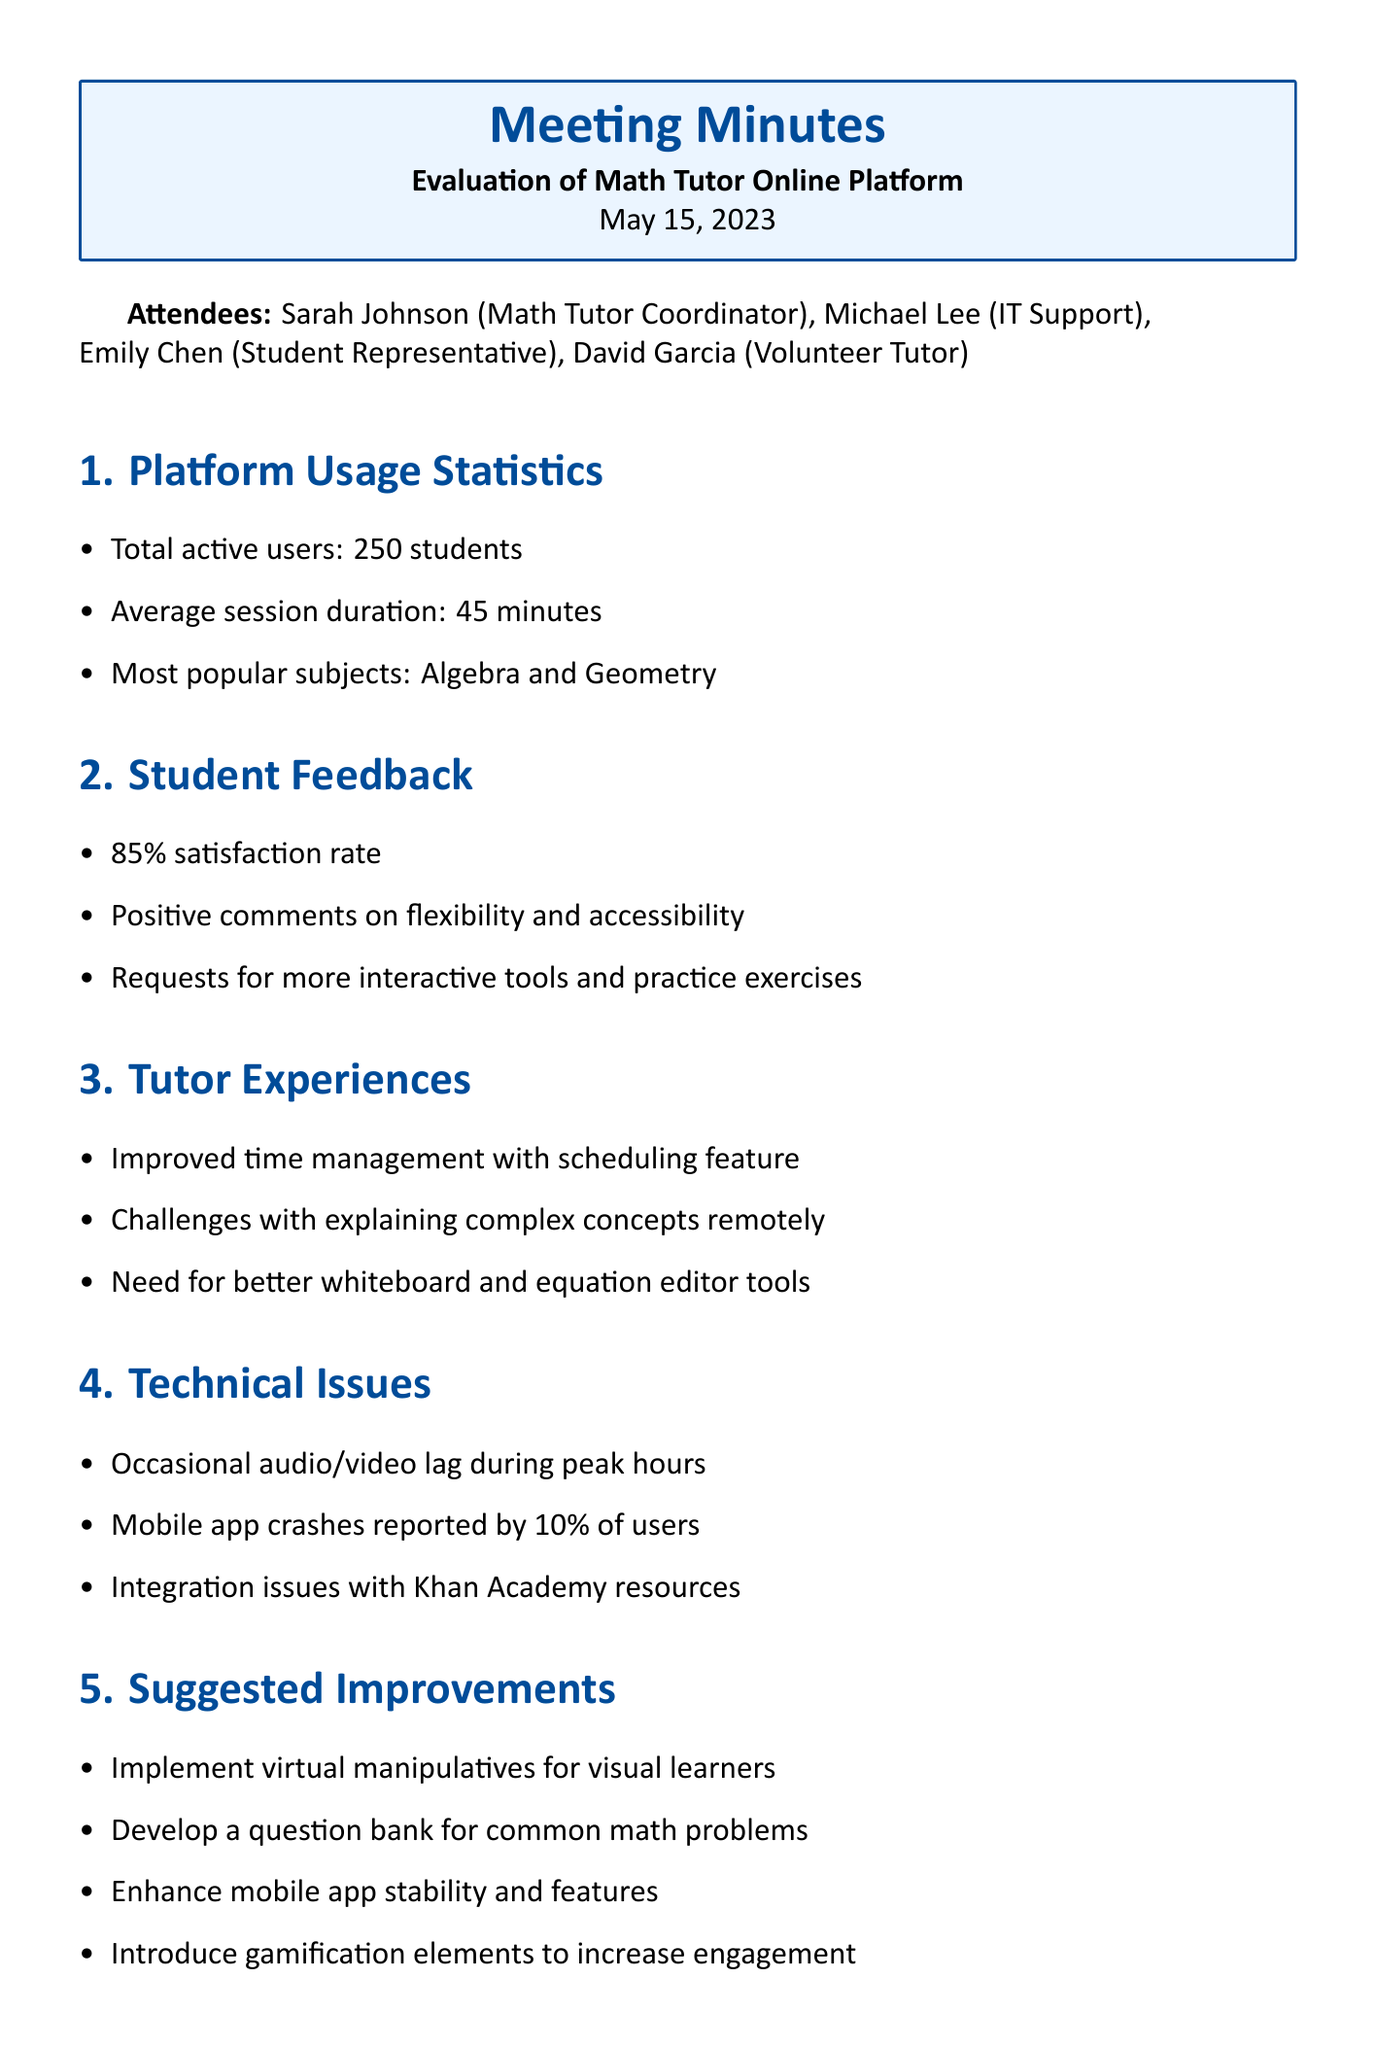What is the total number of active users? The total number of active users is stated in the platform usage statistics section of the document.
Answer: 250 students What is the average session duration? The average session duration is mentioned in the platform usage statistics section, providing a key metric of usage.
Answer: 45 minutes What is the satisfaction rate among students? The satisfaction rate is reported in the student feedback section, reflecting students' contentment with the platform.
Answer: 85% What common issue was reported by 10% of the users? The specific technical issue affecting some users is detailed in the technical issues section, indicating a problem with the platform.
Answer: Mobile app crashes What is one suggestion for improvement related to student engagement? The suggested improvements include various ideas, including enhancing student engagement. One such suggestion is highlighted in the document.
Answer: Introduce gamification elements Why do tutors face challenges in explaining complex concepts? Tutors' experiences are shared in the document, which includes their struggles while working with students online.
Answer: Explaining complex concepts remotely What should be prioritized according to the next steps? The next steps section outlines a course of action, indicating what should be prioritized based on certain criteria.
Answer: Improvements based on impact and feasibility Who should be involved in focus groups? The next steps section specifies who should be involved in these discussions for better insights on the platform.
Answer: Students and tutors What popular subjects were identified in the usage statistics? The popular subjects are mentioned in the platform usage statistics, providing insight into what students are most interested in learning.
Answer: Algebra and Geometry 